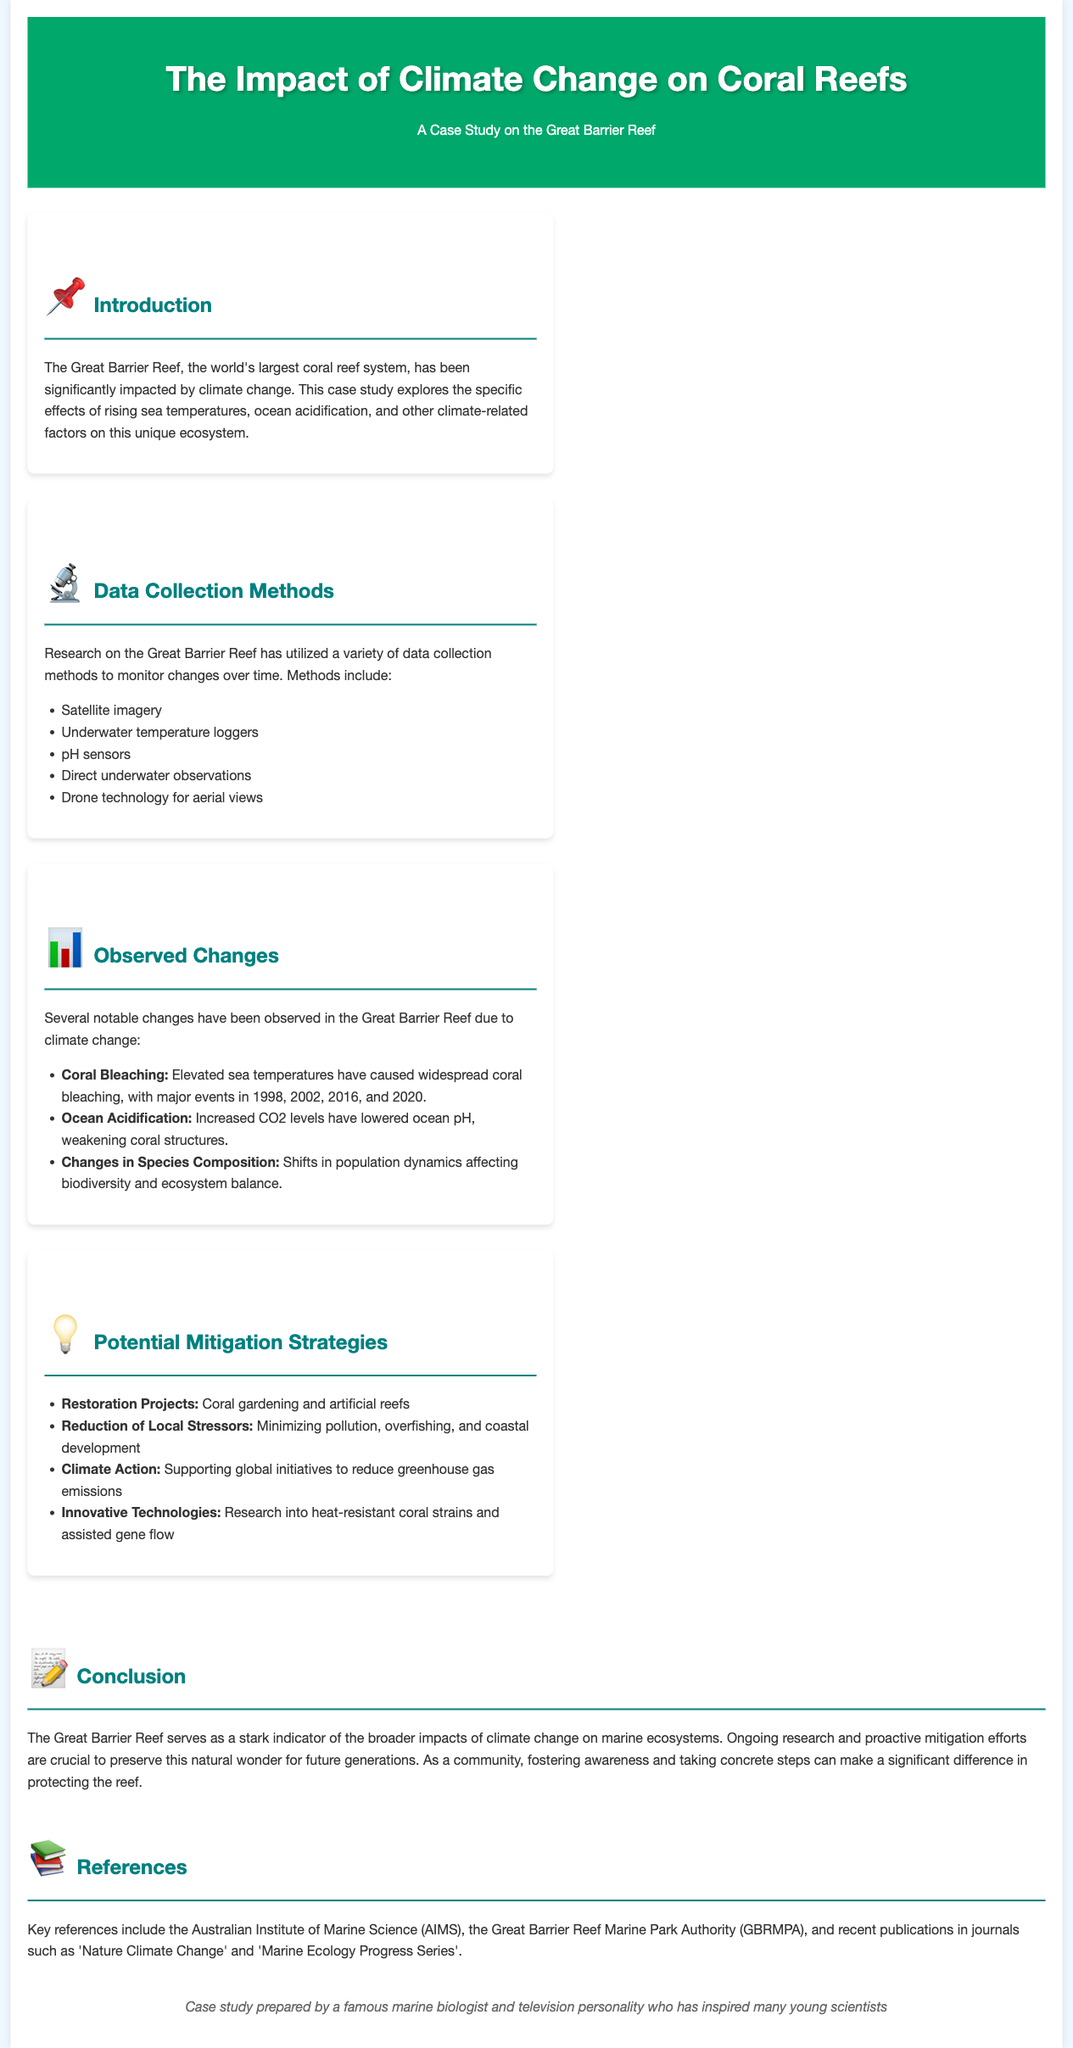What is the world's largest coral reef system? The introduction states that the Great Barrier Reef is the world's largest coral reef system.
Answer: Great Barrier Reef What are two data collection methods used in this study? The document lists various data collection methods, including satellite imagery and underwater temperature loggers among others.
Answer: Satellite imagery, underwater temperature loggers In which years were major coral bleaching events reported? The observed changes section mentions significant coral bleaching events occurring in 1998, 2002, 2016, and 2020.
Answer: 1998, 2002, 2016, 2020 What is one potential mitigation strategy discussed? The document outlines several mitigation strategies, including restoration projects as one of them.
Answer: Restoration Projects What impact does ocean acidification have on coral structures? The section on observed changes discusses that increased CO2 levels have weakened coral structures due to lowered ocean pH.
Answer: Weakening of coral structures What is the main conclusion drawn in the case study? The conclusion emphasizes the Great Barrier Reef as an indicator of climate change impacts and stresses the need for ongoing research and mitigation efforts.
Answer: Preserve this natural wonder for future generations Which organizations are referenced in the document? The references section mentions important organizations such as the Australian Institute of Marine Science and the Great Barrier Reef Marine Park Authority.
Answer: Australian Institute of Marine Science, Great Barrier Reef Marine Park Authority 